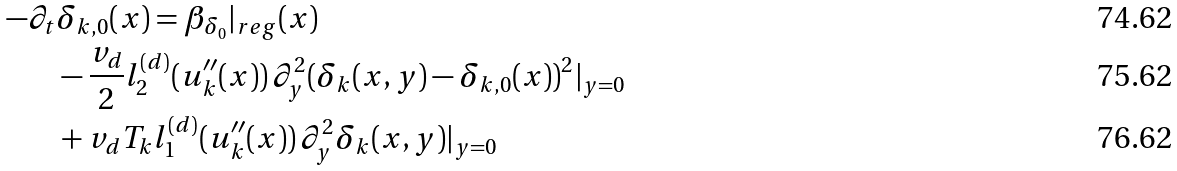Convert formula to latex. <formula><loc_0><loc_0><loc_500><loc_500>- \partial _ { t } & \delta _ { k , 0 } ( x ) = \beta _ { \delta _ { 0 } } | _ { r e g } ( x ) \\ & - \frac { v _ { d } } { 2 } l _ { 2 } ^ { ( d ) } ( u ^ { \prime \prime } _ { k } ( x ) ) \, \partial _ { y } ^ { 2 } ( \delta _ { k } ( x , y ) - \delta _ { k , 0 } ( x ) ) ^ { 2 } | _ { y = 0 } \\ & + v _ { d } T _ { k } l _ { 1 } ^ { ( d ) } ( u ^ { \prime \prime } _ { k } ( x ) ) \, \partial _ { y } ^ { 2 } \delta _ { k } ( x , y ) | _ { y = 0 }</formula> 